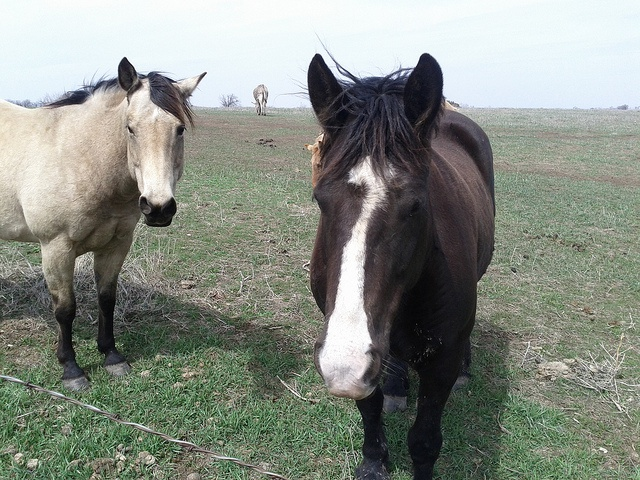Describe the objects in this image and their specific colors. I can see horse in white, black, and gray tones, horse in white, ivory, black, gray, and darkgray tones, horse in white, gray, and tan tones, and horse in white, darkgray, lightgray, and gray tones in this image. 